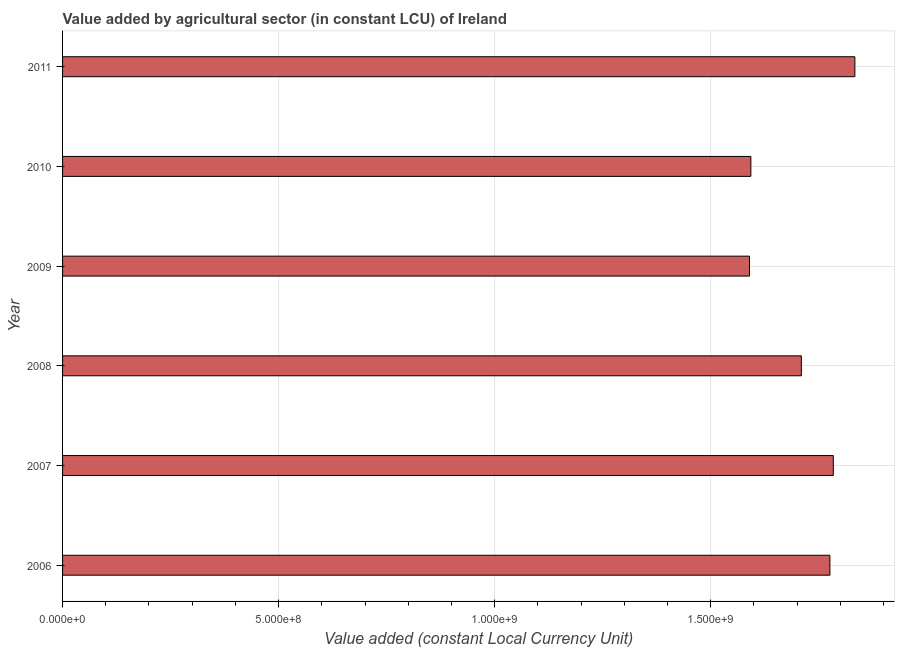Does the graph contain any zero values?
Your response must be concise. No. Does the graph contain grids?
Your answer should be very brief. Yes. What is the title of the graph?
Your answer should be very brief. Value added by agricultural sector (in constant LCU) of Ireland. What is the label or title of the X-axis?
Your answer should be very brief. Value added (constant Local Currency Unit). What is the value added by agriculture sector in 2008?
Provide a short and direct response. 1.71e+09. Across all years, what is the maximum value added by agriculture sector?
Your answer should be very brief. 1.83e+09. Across all years, what is the minimum value added by agriculture sector?
Your answer should be very brief. 1.59e+09. In which year was the value added by agriculture sector maximum?
Your answer should be very brief. 2011. In which year was the value added by agriculture sector minimum?
Offer a very short reply. 2009. What is the sum of the value added by agriculture sector?
Make the answer very short. 1.03e+1. What is the difference between the value added by agriculture sector in 2007 and 2011?
Provide a short and direct response. -5.00e+07. What is the average value added by agriculture sector per year?
Give a very brief answer. 1.71e+09. What is the median value added by agriculture sector?
Offer a terse response. 1.74e+09. Is the value added by agriculture sector in 2010 less than that in 2011?
Offer a very short reply. Yes. Is the difference between the value added by agriculture sector in 2007 and 2008 greater than the difference between any two years?
Make the answer very short. No. What is the difference between the highest and the second highest value added by agriculture sector?
Offer a terse response. 5.00e+07. Is the sum of the value added by agriculture sector in 2008 and 2009 greater than the maximum value added by agriculture sector across all years?
Ensure brevity in your answer.  Yes. What is the difference between the highest and the lowest value added by agriculture sector?
Offer a very short reply. 2.44e+08. In how many years, is the value added by agriculture sector greater than the average value added by agriculture sector taken over all years?
Provide a succinct answer. 3. Are all the bars in the graph horizontal?
Keep it short and to the point. Yes. What is the Value added (constant Local Currency Unit) in 2006?
Offer a very short reply. 1.78e+09. What is the Value added (constant Local Currency Unit) of 2007?
Your answer should be very brief. 1.78e+09. What is the Value added (constant Local Currency Unit) in 2008?
Give a very brief answer. 1.71e+09. What is the Value added (constant Local Currency Unit) in 2009?
Give a very brief answer. 1.59e+09. What is the Value added (constant Local Currency Unit) in 2010?
Provide a succinct answer. 1.59e+09. What is the Value added (constant Local Currency Unit) in 2011?
Your response must be concise. 1.83e+09. What is the difference between the Value added (constant Local Currency Unit) in 2006 and 2007?
Offer a very short reply. -7.84e+06. What is the difference between the Value added (constant Local Currency Unit) in 2006 and 2008?
Keep it short and to the point. 6.60e+07. What is the difference between the Value added (constant Local Currency Unit) in 2006 and 2009?
Provide a succinct answer. 1.86e+08. What is the difference between the Value added (constant Local Currency Unit) in 2006 and 2010?
Offer a terse response. 1.83e+08. What is the difference between the Value added (constant Local Currency Unit) in 2006 and 2011?
Provide a short and direct response. -5.78e+07. What is the difference between the Value added (constant Local Currency Unit) in 2007 and 2008?
Provide a short and direct response. 7.39e+07. What is the difference between the Value added (constant Local Currency Unit) in 2007 and 2009?
Offer a very short reply. 1.94e+08. What is the difference between the Value added (constant Local Currency Unit) in 2007 and 2010?
Your answer should be very brief. 1.91e+08. What is the difference between the Value added (constant Local Currency Unit) in 2007 and 2011?
Provide a succinct answer. -5.00e+07. What is the difference between the Value added (constant Local Currency Unit) in 2008 and 2009?
Offer a terse response. 1.20e+08. What is the difference between the Value added (constant Local Currency Unit) in 2008 and 2010?
Provide a succinct answer. 1.17e+08. What is the difference between the Value added (constant Local Currency Unit) in 2008 and 2011?
Provide a succinct answer. -1.24e+08. What is the difference between the Value added (constant Local Currency Unit) in 2009 and 2010?
Provide a succinct answer. -3.12e+06. What is the difference between the Value added (constant Local Currency Unit) in 2009 and 2011?
Ensure brevity in your answer.  -2.44e+08. What is the difference between the Value added (constant Local Currency Unit) in 2010 and 2011?
Keep it short and to the point. -2.41e+08. What is the ratio of the Value added (constant Local Currency Unit) in 2006 to that in 2007?
Provide a short and direct response. 1. What is the ratio of the Value added (constant Local Currency Unit) in 2006 to that in 2008?
Ensure brevity in your answer.  1.04. What is the ratio of the Value added (constant Local Currency Unit) in 2006 to that in 2009?
Provide a short and direct response. 1.12. What is the ratio of the Value added (constant Local Currency Unit) in 2006 to that in 2010?
Your answer should be compact. 1.11. What is the ratio of the Value added (constant Local Currency Unit) in 2007 to that in 2008?
Provide a short and direct response. 1.04. What is the ratio of the Value added (constant Local Currency Unit) in 2007 to that in 2009?
Your response must be concise. 1.12. What is the ratio of the Value added (constant Local Currency Unit) in 2007 to that in 2010?
Your answer should be compact. 1.12. What is the ratio of the Value added (constant Local Currency Unit) in 2007 to that in 2011?
Provide a succinct answer. 0.97. What is the ratio of the Value added (constant Local Currency Unit) in 2008 to that in 2009?
Your answer should be very brief. 1.07. What is the ratio of the Value added (constant Local Currency Unit) in 2008 to that in 2010?
Ensure brevity in your answer.  1.07. What is the ratio of the Value added (constant Local Currency Unit) in 2008 to that in 2011?
Your response must be concise. 0.93. What is the ratio of the Value added (constant Local Currency Unit) in 2009 to that in 2010?
Keep it short and to the point. 1. What is the ratio of the Value added (constant Local Currency Unit) in 2009 to that in 2011?
Your answer should be very brief. 0.87. What is the ratio of the Value added (constant Local Currency Unit) in 2010 to that in 2011?
Provide a short and direct response. 0.87. 